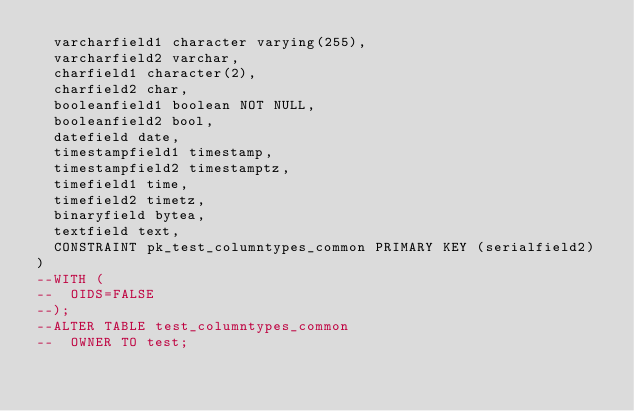<code> <loc_0><loc_0><loc_500><loc_500><_SQL_>  varcharfield1 character varying(255),
  varcharfield2 varchar,
  charfield1 character(2),
  charfield2 char,
  booleanfield1 boolean NOT NULL,
  booleanfield2 bool,
  datefield date,
  timestampfield1 timestamp,
  timestampfield2 timestamptz,
  timefield1 time,
  timefield2 timetz,
  binaryfield bytea,
  textfield text,
  CONSTRAINT pk_test_columntypes_common PRIMARY KEY (serialfield2)
)
--WITH (
--  OIDS=FALSE
--);
--ALTER TABLE test_columntypes_common
--  OWNER TO test;
</code> 